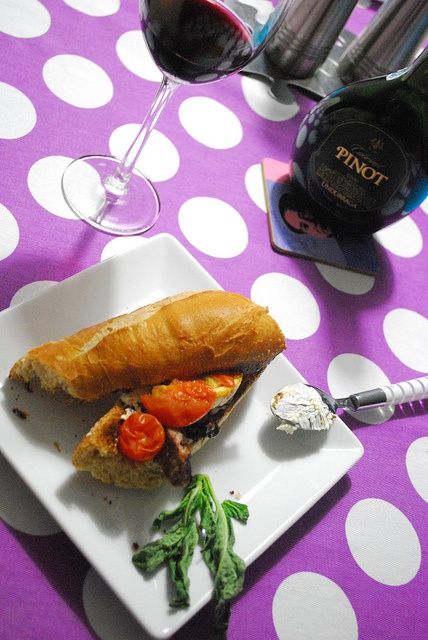Describe the objects in this image and their specific colors. I can see dining table in white, black, violet, lightgray, and gray tones, sandwich in lightgray, red, maroon, black, and orange tones, bottle in lightgray, black, gray, navy, and darkgray tones, wine glass in lightgray, black, white, violet, and darkgray tones, and spoon in lightgray, white, darkgray, gray, and beige tones in this image. 